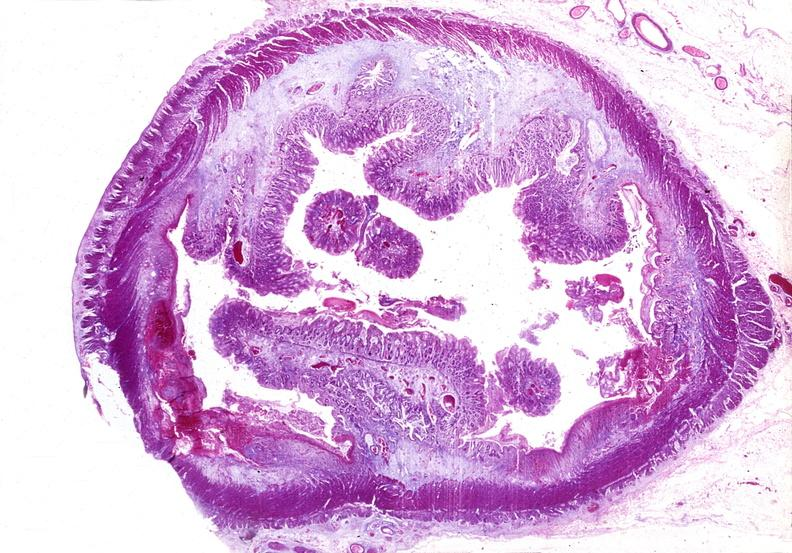what does this image show?
Answer the question using a single word or phrase. Colon 